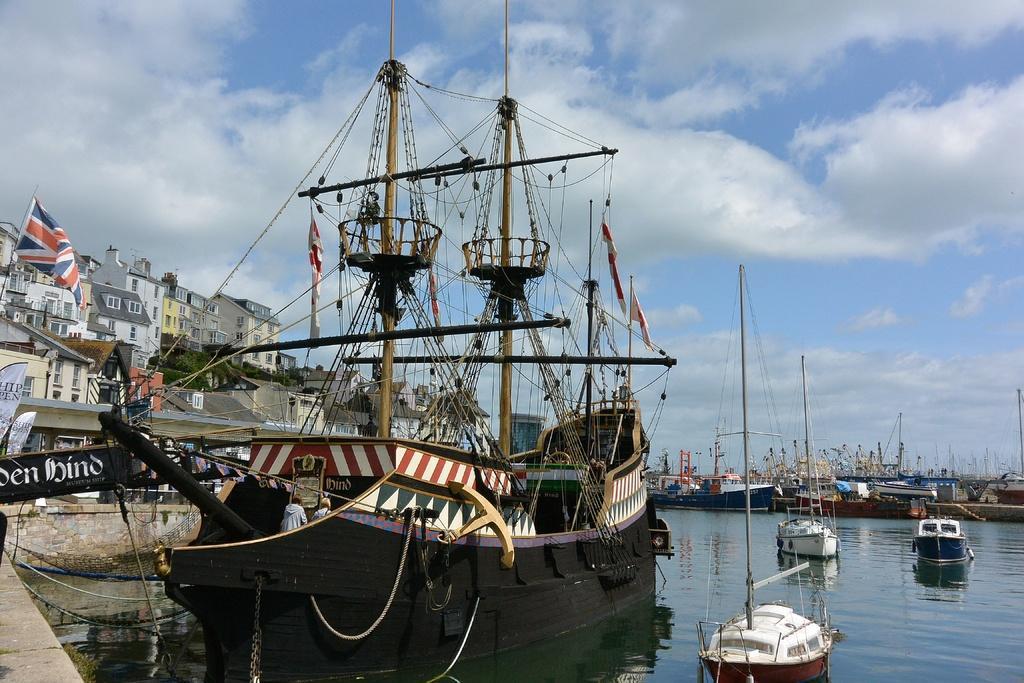Describe this image in one or two sentences. In the picture there are ships and boats in the water. On the left there are buildings and flag. Sky is cloudy. 